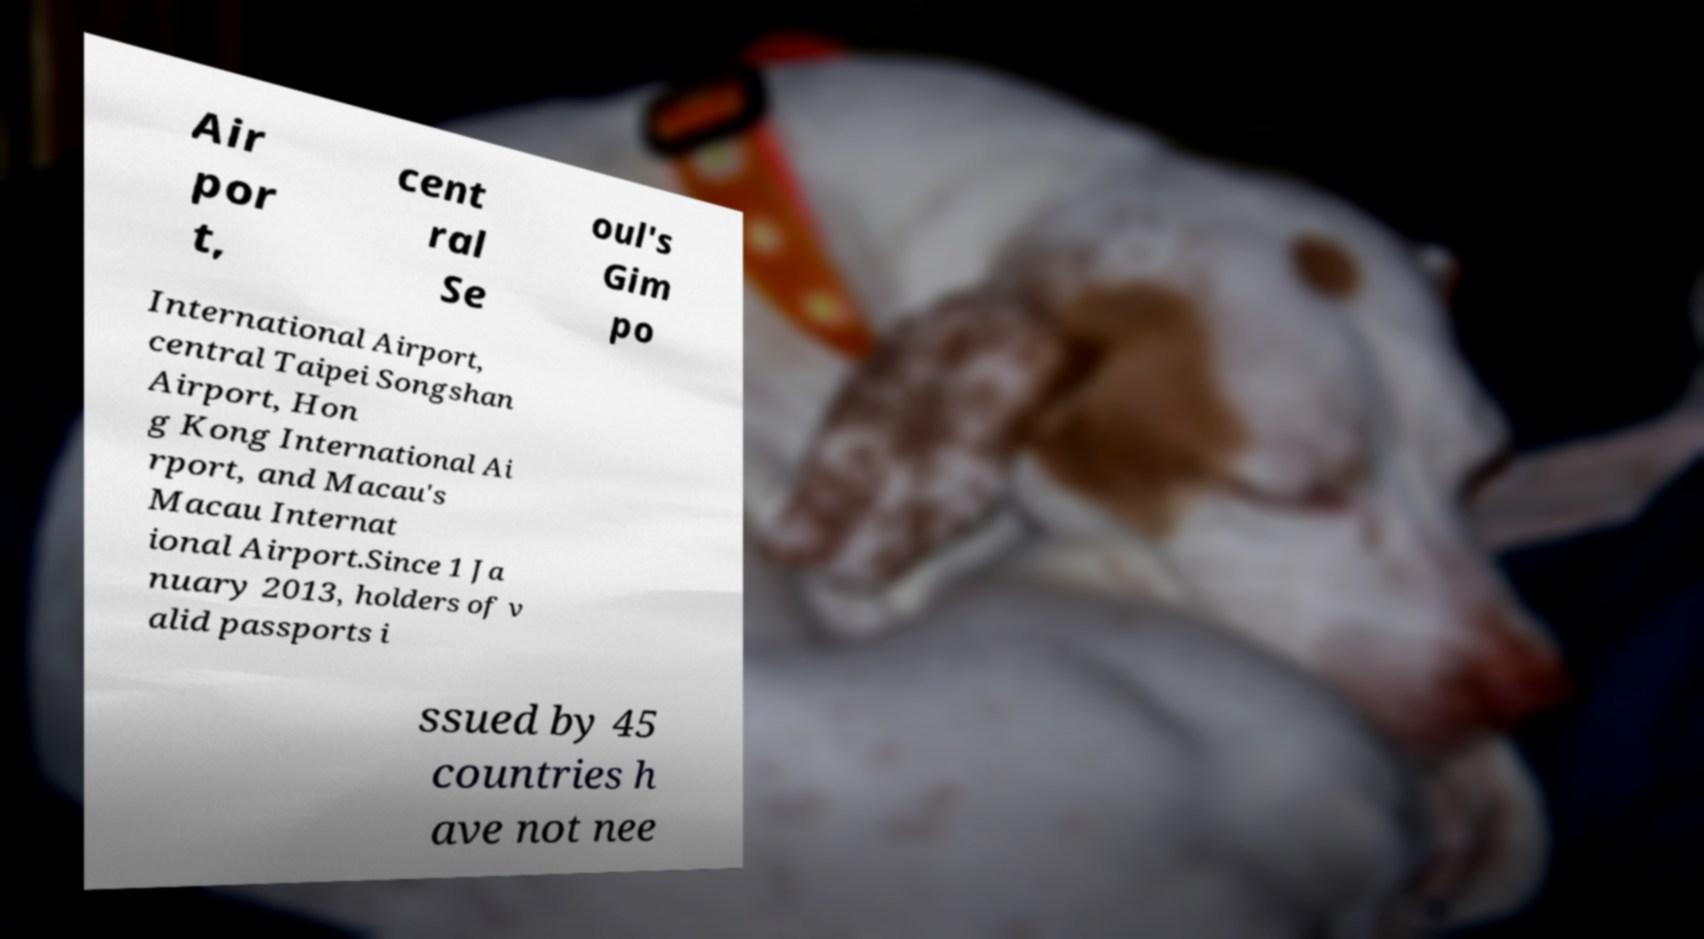Can you accurately transcribe the text from the provided image for me? Air por t, cent ral Se oul's Gim po International Airport, central Taipei Songshan Airport, Hon g Kong International Ai rport, and Macau's Macau Internat ional Airport.Since 1 Ja nuary 2013, holders of v alid passports i ssued by 45 countries h ave not nee 